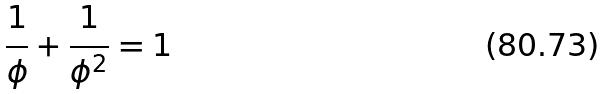Convert formula to latex. <formula><loc_0><loc_0><loc_500><loc_500>\frac { 1 } { \phi } + \frac { 1 } { \phi ^ { 2 } } = 1</formula> 